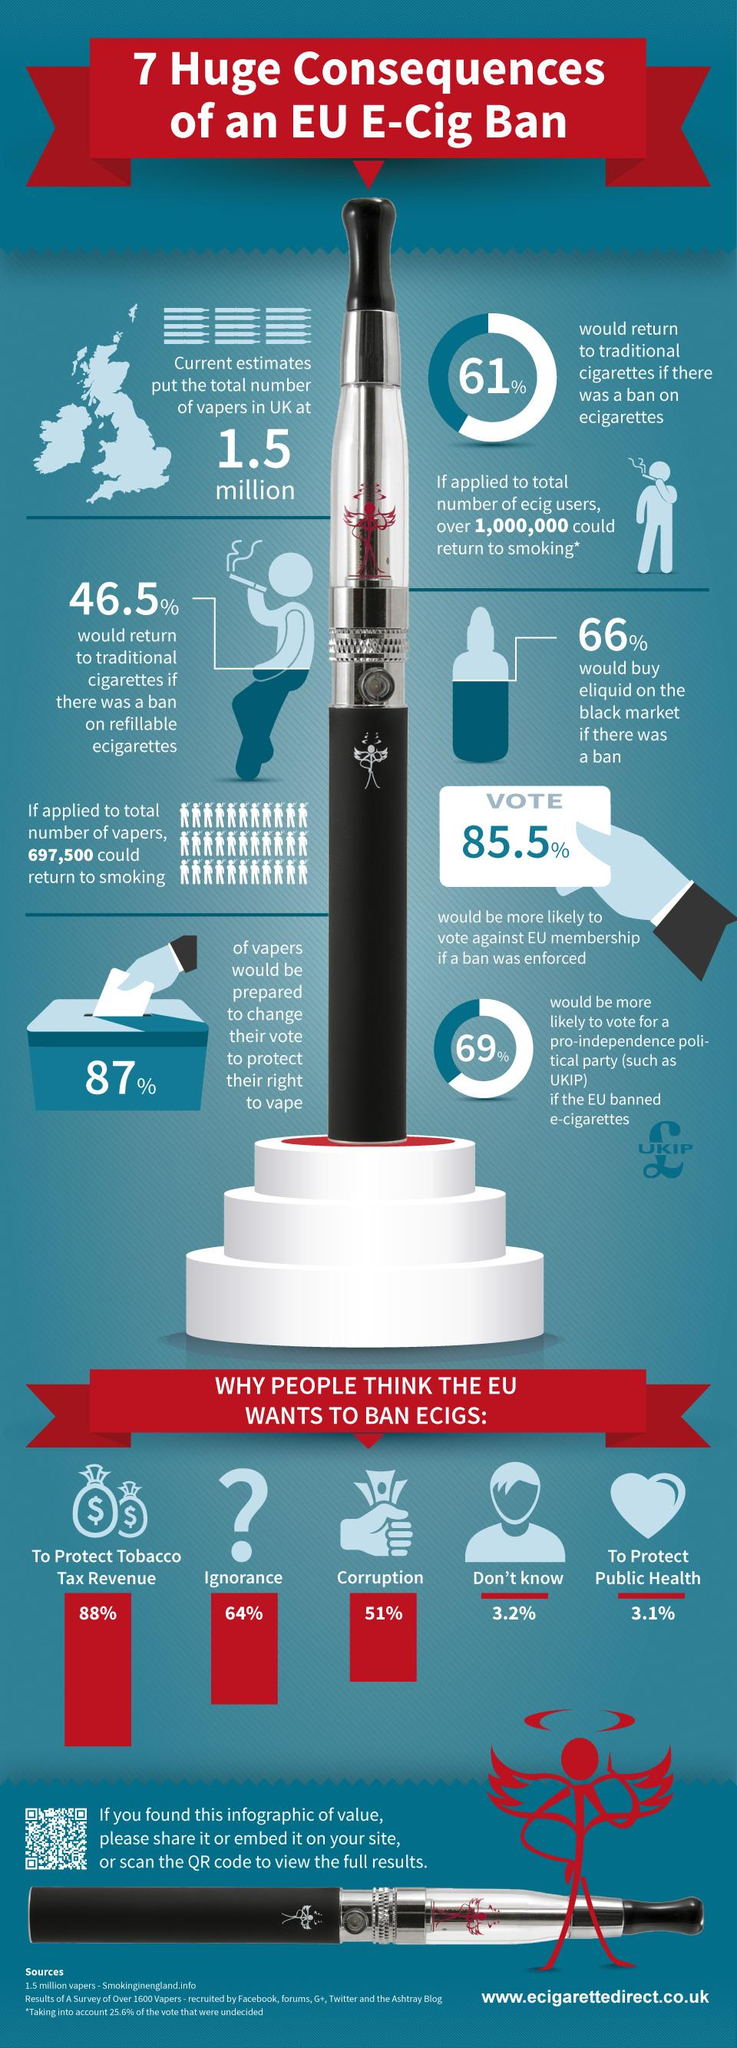Mention a couple of crucial points in this snapshot. According to a survey, only 3.1% of people believe that the EU is banning e-cigarettes in order to protect public health. It is estimated that there are approximately 1.5 million vapers in the UK. According to a recent survey, a significant percentage of people believe that the EU is banning e-cigarettes due to corruption, with 51% of respondents stating this. A recent survey found that 88% of people believe that the EU is seeking to ban e-cigarettes in order to protect tobacco tax revenue. 